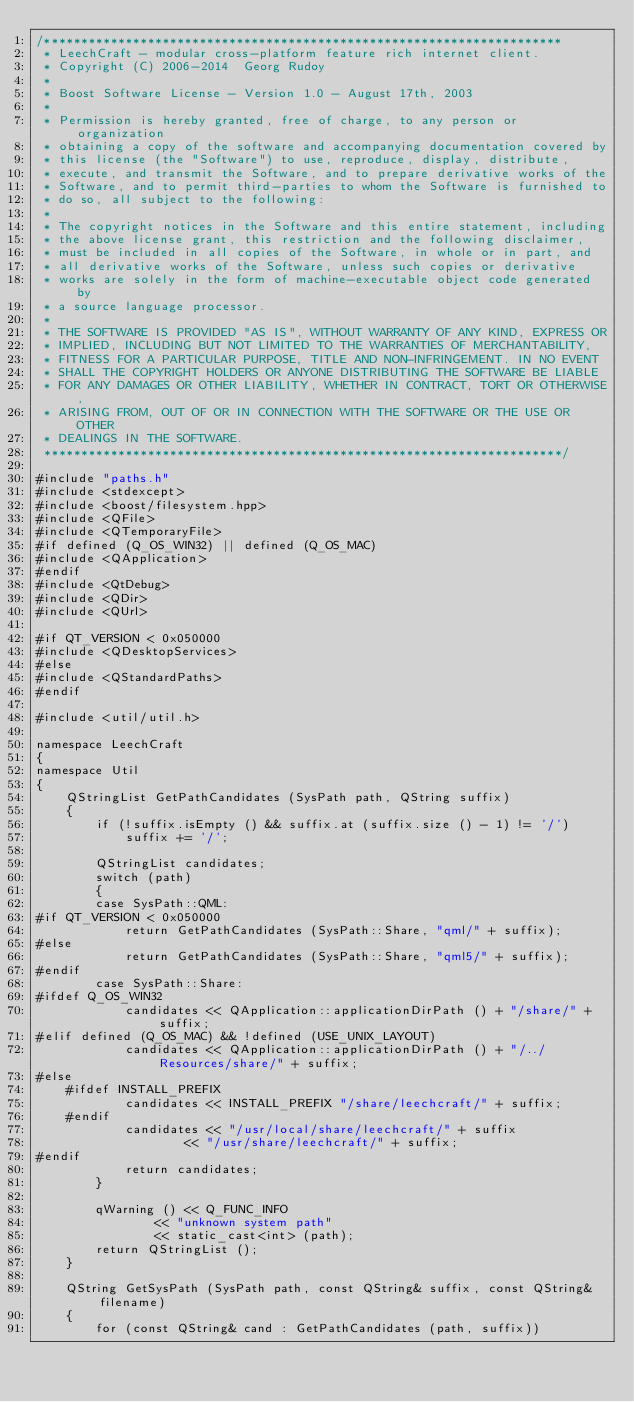<code> <loc_0><loc_0><loc_500><loc_500><_C++_>/**********************************************************************
 * LeechCraft - modular cross-platform feature rich internet client.
 * Copyright (C) 2006-2014  Georg Rudoy
 *
 * Boost Software License - Version 1.0 - August 17th, 2003
 *
 * Permission is hereby granted, free of charge, to any person or organization
 * obtaining a copy of the software and accompanying documentation covered by
 * this license (the "Software") to use, reproduce, display, distribute,
 * execute, and transmit the Software, and to prepare derivative works of the
 * Software, and to permit third-parties to whom the Software is furnished to
 * do so, all subject to the following:
 *
 * The copyright notices in the Software and this entire statement, including
 * the above license grant, this restriction and the following disclaimer,
 * must be included in all copies of the Software, in whole or in part, and
 * all derivative works of the Software, unless such copies or derivative
 * works are solely in the form of machine-executable object code generated by
 * a source language processor.
 *
 * THE SOFTWARE IS PROVIDED "AS IS", WITHOUT WARRANTY OF ANY KIND, EXPRESS OR
 * IMPLIED, INCLUDING BUT NOT LIMITED TO THE WARRANTIES OF MERCHANTABILITY,
 * FITNESS FOR A PARTICULAR PURPOSE, TITLE AND NON-INFRINGEMENT. IN NO EVENT
 * SHALL THE COPYRIGHT HOLDERS OR ANYONE DISTRIBUTING THE SOFTWARE BE LIABLE
 * FOR ANY DAMAGES OR OTHER LIABILITY, WHETHER IN CONTRACT, TORT OR OTHERWISE,
 * ARISING FROM, OUT OF OR IN CONNECTION WITH THE SOFTWARE OR THE USE OR OTHER
 * DEALINGS IN THE SOFTWARE.
 **********************************************************************/

#include "paths.h"
#include <stdexcept>
#include <boost/filesystem.hpp>
#include <QFile>
#include <QTemporaryFile>
#if defined (Q_OS_WIN32) || defined (Q_OS_MAC)
#include <QApplication>
#endif
#include <QtDebug>
#include <QDir>
#include <QUrl>

#if QT_VERSION < 0x050000
#include <QDesktopServices>
#else
#include <QStandardPaths>
#endif

#include <util/util.h>

namespace LeechCraft
{
namespace Util
{
	QStringList GetPathCandidates (SysPath path, QString suffix)
	{
		if (!suffix.isEmpty () && suffix.at (suffix.size () - 1) != '/')
			suffix += '/';

		QStringList candidates;
		switch (path)
		{
		case SysPath::QML:
#if QT_VERSION < 0x050000
			return GetPathCandidates (SysPath::Share, "qml/" + suffix);
#else
			return GetPathCandidates (SysPath::Share, "qml5/" + suffix);
#endif
		case SysPath::Share:
#ifdef Q_OS_WIN32
			candidates << QApplication::applicationDirPath () + "/share/" + suffix;
#elif defined (Q_OS_MAC) && !defined (USE_UNIX_LAYOUT)
			candidates << QApplication::applicationDirPath () + "/../Resources/share/" + suffix;
#else
	#ifdef INSTALL_PREFIX
			candidates << INSTALL_PREFIX "/share/leechcraft/" + suffix;
	#endif
			candidates << "/usr/local/share/leechcraft/" + suffix
					<< "/usr/share/leechcraft/" + suffix;
#endif
			return candidates;
		}

		qWarning () << Q_FUNC_INFO
				<< "unknown system path"
				<< static_cast<int> (path);
		return QStringList ();
	}

	QString GetSysPath (SysPath path, const QString& suffix, const QString& filename)
	{
		for (const QString& cand : GetPathCandidates (path, suffix))</code> 